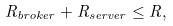Convert formula to latex. <formula><loc_0><loc_0><loc_500><loc_500>R _ { b r o k e r } + R _ { s e r v e r } \leq R ,</formula> 